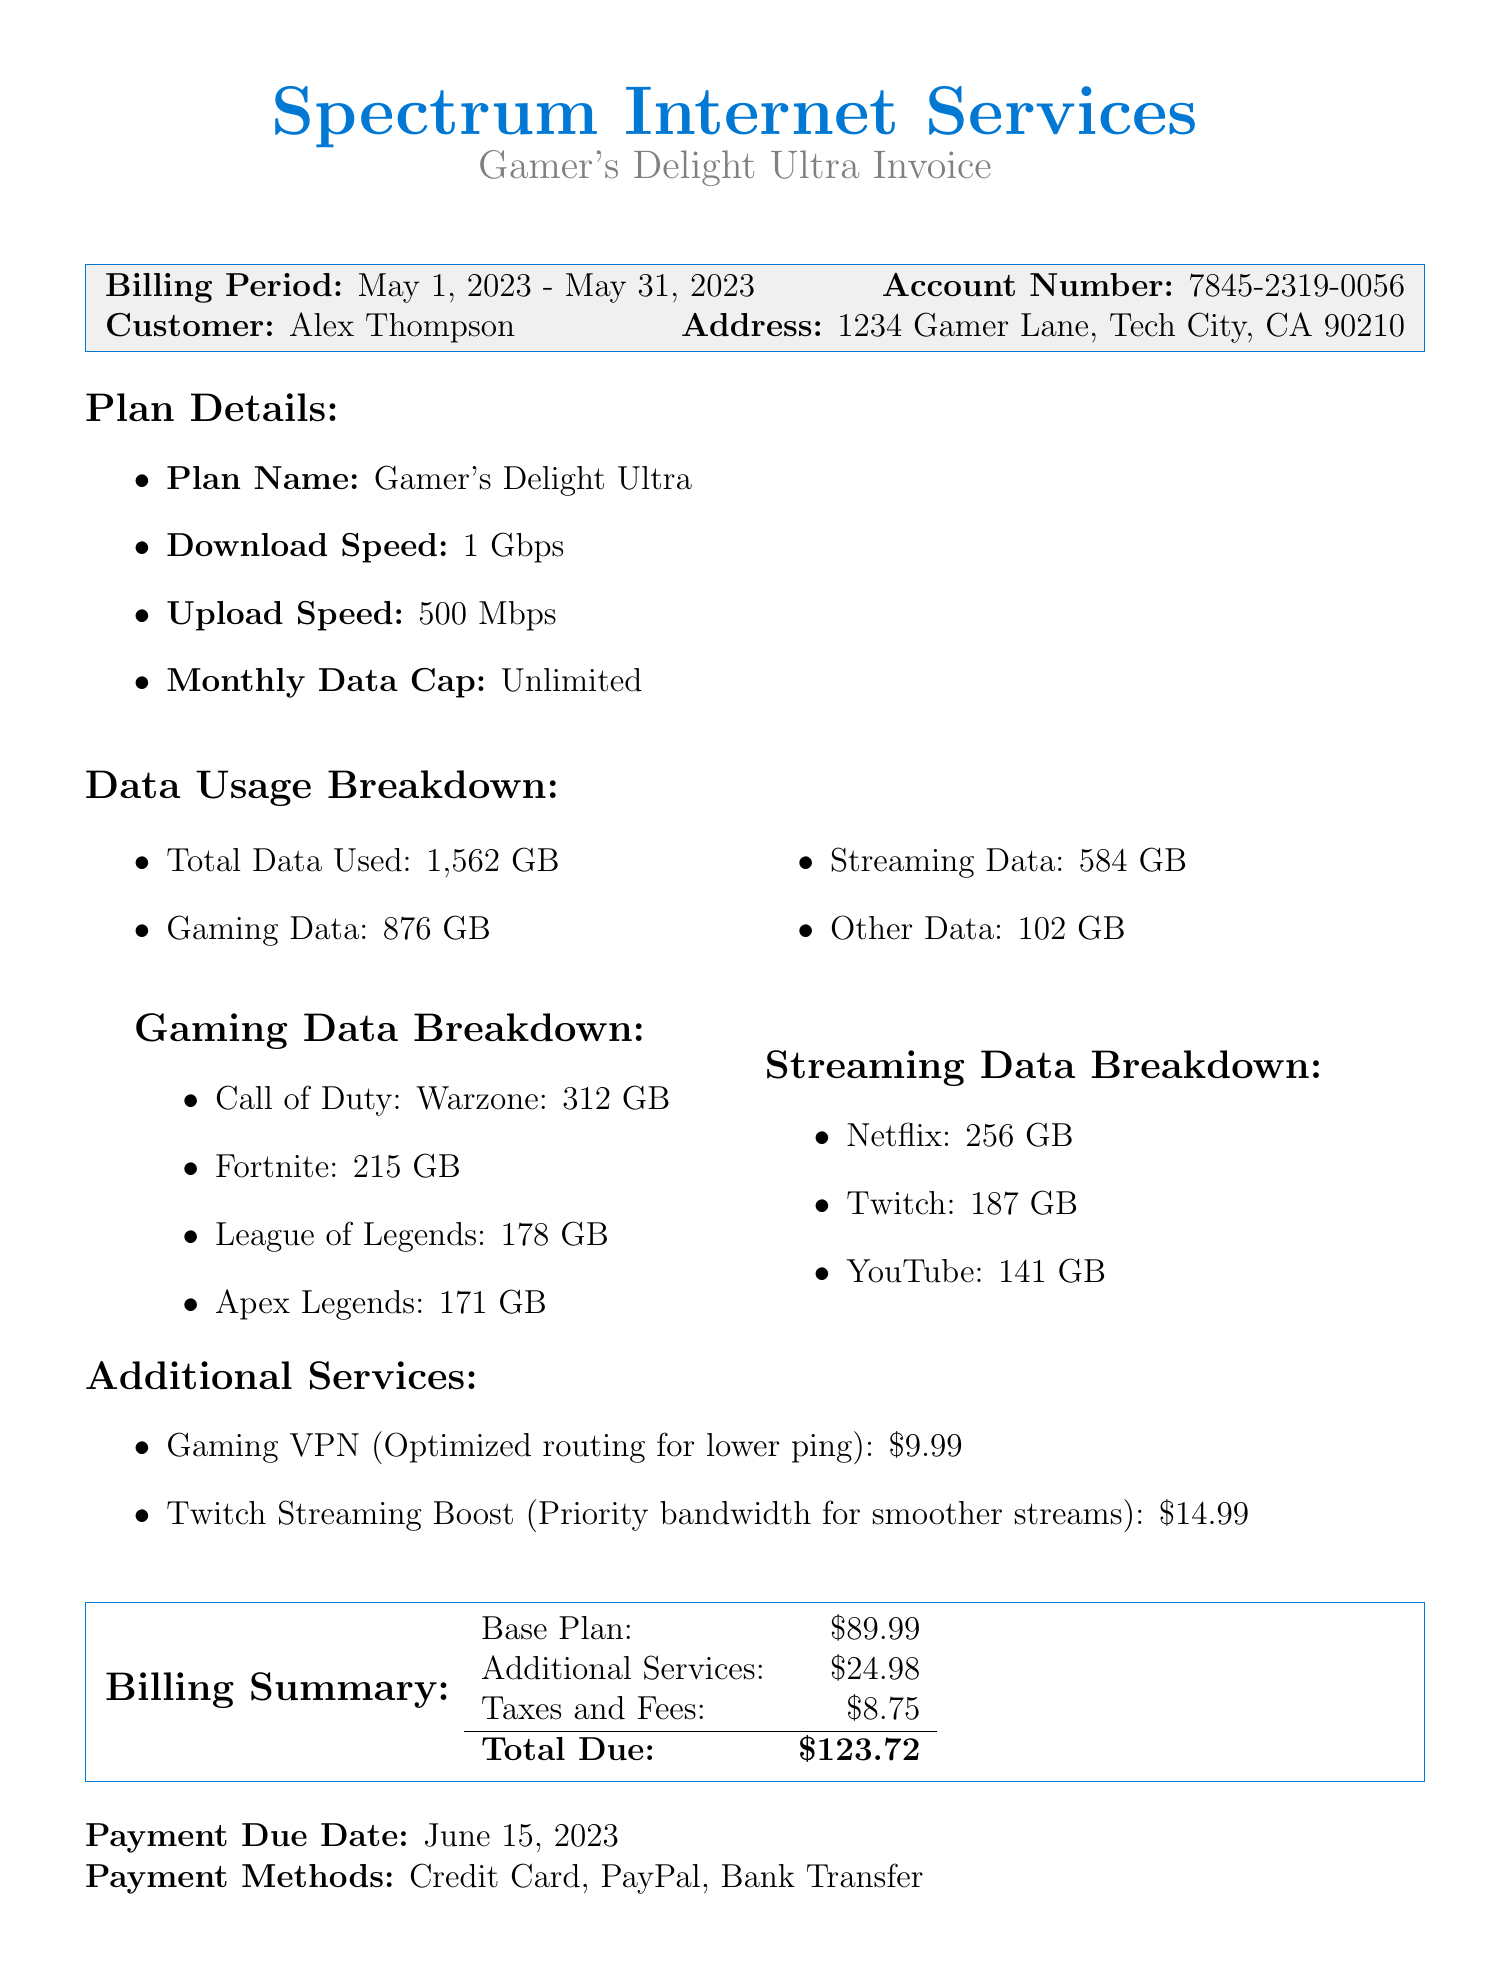What is the total data used in May? The total data used is mentioned in the data usage section of the invoice as 1,562 GB.
Answer: 1,562 GB How much gaming data was used? The gaming data usage is specified as 876 GB in the data usage section.
Answer: 876 GB What is the name of the internet plan? The plan name is indicated under plan details as "Gamer's Delight Ultra."
Answer: Gamer's Delight Ultra Which game used the most data? The gaming breakdown shows that "Call of Duty: Warzone" used the most data at 312 GB.
Answer: Call of Duty: Warzone How much is the total due? The total due is provided in the billing summary section as $123.72.
Answer: $123.72 What is the price for the Gaming VPN service? The invoice lists the price of the Gaming VPN service as $9.99.
Answer: $9.99 When is the payment due date? The payment due date is stated clearly in the document as June 15, 2023.
Answer: June 15, 2023 What type of support does the customer service offer? The customer support section provides multiple contact methods including phone, email, and live chat.
Answer: Phone, email, live chat How much additional cost is there to upgrade to 2 Gbps? The cost increase for upgrading to 2 Gbps is specified as $20.00.
Answer: $20.00 